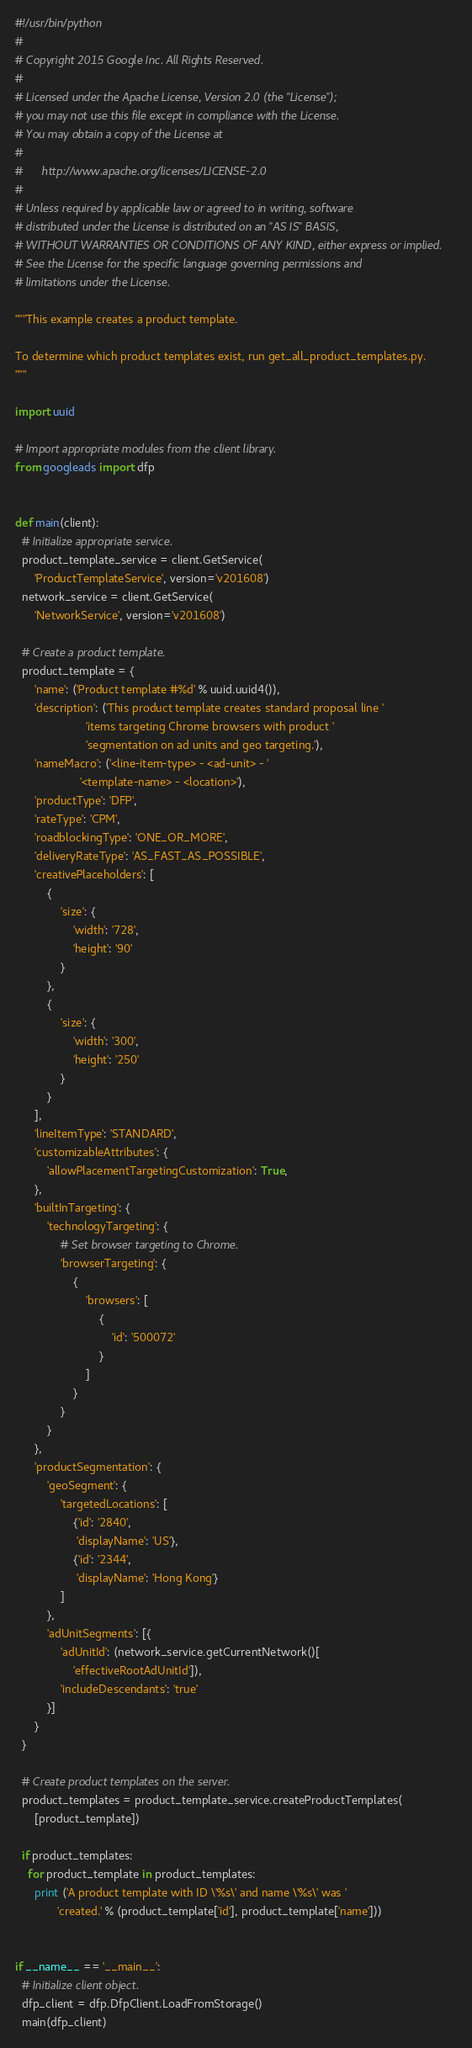<code> <loc_0><loc_0><loc_500><loc_500><_Python_>#!/usr/bin/python
#
# Copyright 2015 Google Inc. All Rights Reserved.
#
# Licensed under the Apache License, Version 2.0 (the "License");
# you may not use this file except in compliance with the License.
# You may obtain a copy of the License at
#
#      http://www.apache.org/licenses/LICENSE-2.0
#
# Unless required by applicable law or agreed to in writing, software
# distributed under the License is distributed on an "AS IS" BASIS,
# WITHOUT WARRANTIES OR CONDITIONS OF ANY KIND, either express or implied.
# See the License for the specific language governing permissions and
# limitations under the License.

"""This example creates a product template.

To determine which product templates exist, run get_all_product_templates.py.
"""

import uuid

# Import appropriate modules from the client library.
from googleads import dfp


def main(client):
  # Initialize appropriate service.
  product_template_service = client.GetService(
      'ProductTemplateService', version='v201608')
  network_service = client.GetService(
      'NetworkService', version='v201608')

  # Create a product template.
  product_template = {
      'name': ('Product template #%d' % uuid.uuid4()),
      'description': ('This product template creates standard proposal line '
                      'items targeting Chrome browsers with product '
                      'segmentation on ad units and geo targeting.'),
      'nameMacro': ('<line-item-type> - <ad-unit> - '
                    '<template-name> - <location>'),
      'productType': 'DFP',
      'rateType': 'CPM',
      'roadblockingType': 'ONE_OR_MORE',
      'deliveryRateType': 'AS_FAST_AS_POSSIBLE',
      'creativePlaceholders': [
          {
              'size': {
                  'width': '728',
                  'height': '90'
              }
          },
          {
              'size': {
                  'width': '300',
                  'height': '250'
              }
          }
      ],
      'lineItemType': 'STANDARD',
      'customizableAttributes': {
          'allowPlacementTargetingCustomization': True,
      },
      'builtInTargeting': {
          'technologyTargeting': {
              # Set browser targeting to Chrome.
              'browserTargeting': {
                  {
                      'browsers': [
                          {
                              'id': '500072'
                          }
                      ]
                  }
              }
          }
      },
      'productSegmentation': {
          'geoSegment': {
              'targetedLocations': [
                  {'id': '2840',
                   'displayName': 'US'},
                  {'id': '2344',
                   'displayName': 'Hong Kong'}
              ]
          },
          'adUnitSegments': [{
              'adUnitId': (network_service.getCurrentNetwork()[
                  'effectiveRootAdUnitId']),
              'includeDescendants': 'true'
          }]
      }
  }

  # Create product templates on the server.
  product_templates = product_template_service.createProductTemplates(
      [product_template])

  if product_templates:
    for product_template in product_templates:
      print ('A product template with ID \'%s\' and name \'%s\' was '
             'created.' % (product_template['id'], product_template['name']))


if __name__ == '__main__':
  # Initialize client object.
  dfp_client = dfp.DfpClient.LoadFromStorage()
  main(dfp_client)
</code> 